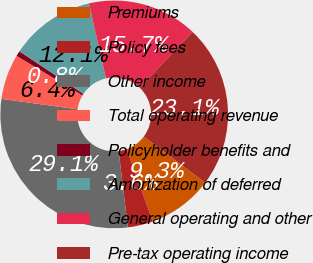Convert chart to OTSL. <chart><loc_0><loc_0><loc_500><loc_500><pie_chart><fcel>Premiums<fcel>Policy fees<fcel>Other income<fcel>Total operating revenue<fcel>Policyholder benefits and<fcel>Amortization of deferred<fcel>General operating and other<fcel>Pre-tax operating income<nl><fcel>9.25%<fcel>3.58%<fcel>29.1%<fcel>6.42%<fcel>0.75%<fcel>12.09%<fcel>15.67%<fcel>23.13%<nl></chart> 